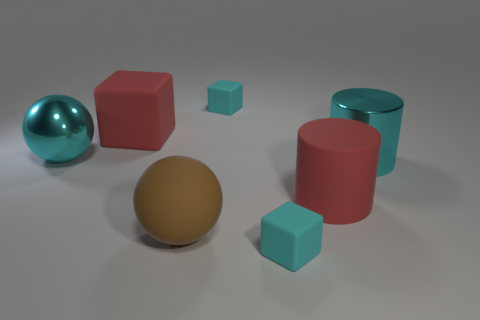Add 2 big rubber things. How many objects exist? 9 Subtract all cylinders. How many objects are left? 5 Subtract all large metallic balls. Subtract all large red rubber cubes. How many objects are left? 5 Add 3 metallic cylinders. How many metallic cylinders are left? 4 Add 7 tiny green rubber cylinders. How many tiny green rubber cylinders exist? 7 Subtract 0 green blocks. How many objects are left? 7 